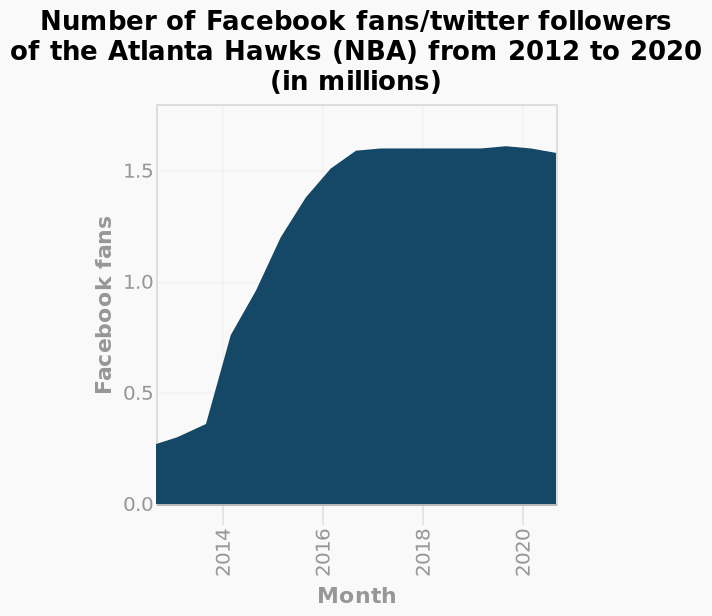<image>
What variable does the x-axis of the chart represent?  The x-axis of the chart represents the variable "Month." What is the color that represents the overall increase in fans?  The overall increase in fans is marked in dark blue. What unit is used to measure the quantity on the y-axis? The quantity on the y-axis is measured in millions. 